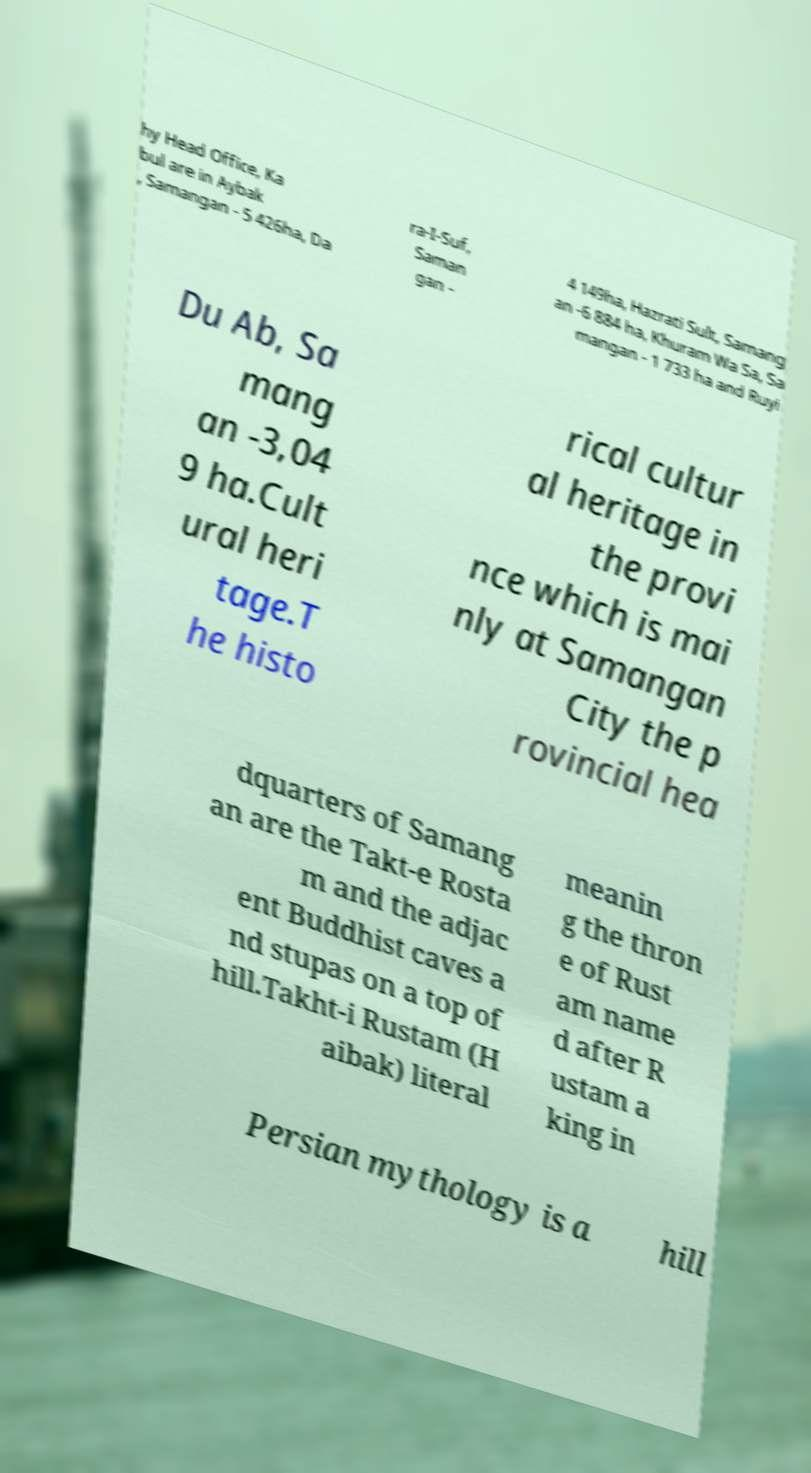There's text embedded in this image that I need extracted. Can you transcribe it verbatim? hy Head Office, Ka bul are in Aybak , Samangan - 5 426ha, Da ra-I-Suf, Saman gan - 4 149ha, Hazrati Sult, Samang an -6 884 ha, Khuram Wa Sa, Sa mangan - 1 733 ha and Ruyi Du Ab, Sa mang an -3,04 9 ha.Cult ural heri tage.T he histo rical cultur al heritage in the provi nce which is mai nly at Samangan City the p rovincial hea dquarters of Samang an are the Takt-e Rosta m and the adjac ent Buddhist caves a nd stupas on a top of hill.Takht-i Rustam (H aibak) literal meanin g the thron e of Rust am name d after R ustam a king in Persian mythology is a hill 